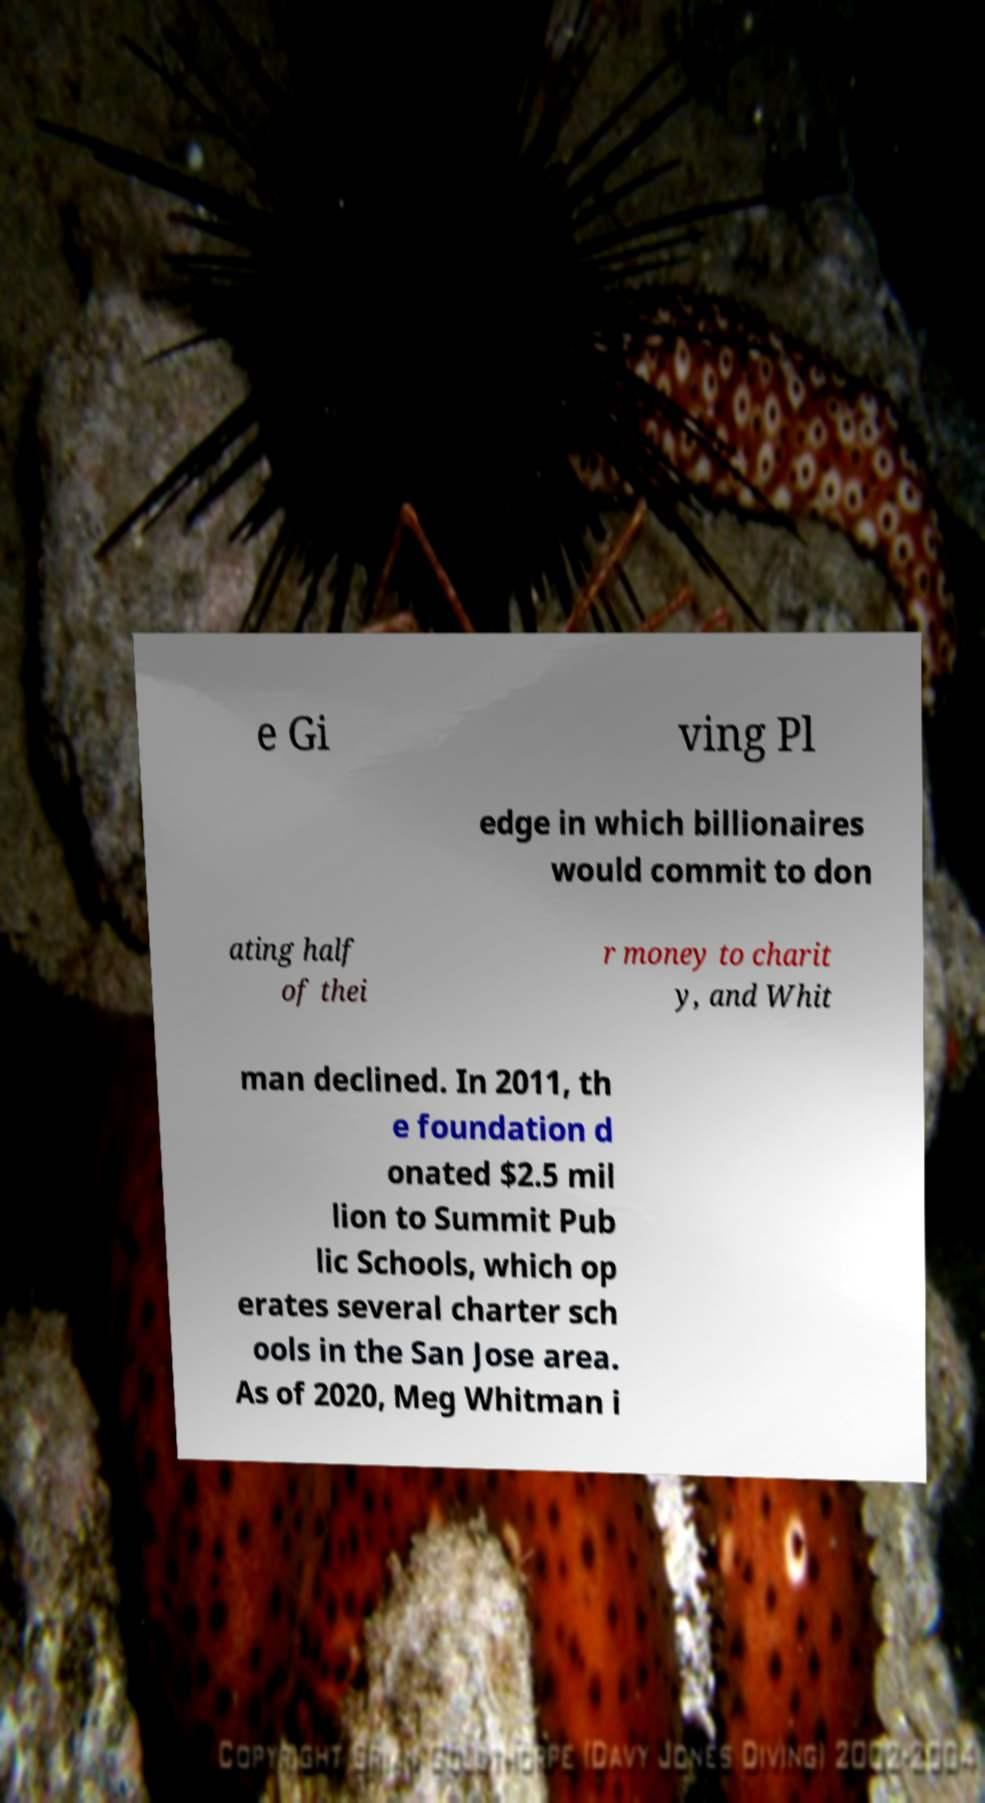For documentation purposes, I need the text within this image transcribed. Could you provide that? e Gi ving Pl edge in which billionaires would commit to don ating half of thei r money to charit y, and Whit man declined. In 2011, th e foundation d onated $2.5 mil lion to Summit Pub lic Schools, which op erates several charter sch ools in the San Jose area. As of 2020, Meg Whitman i 